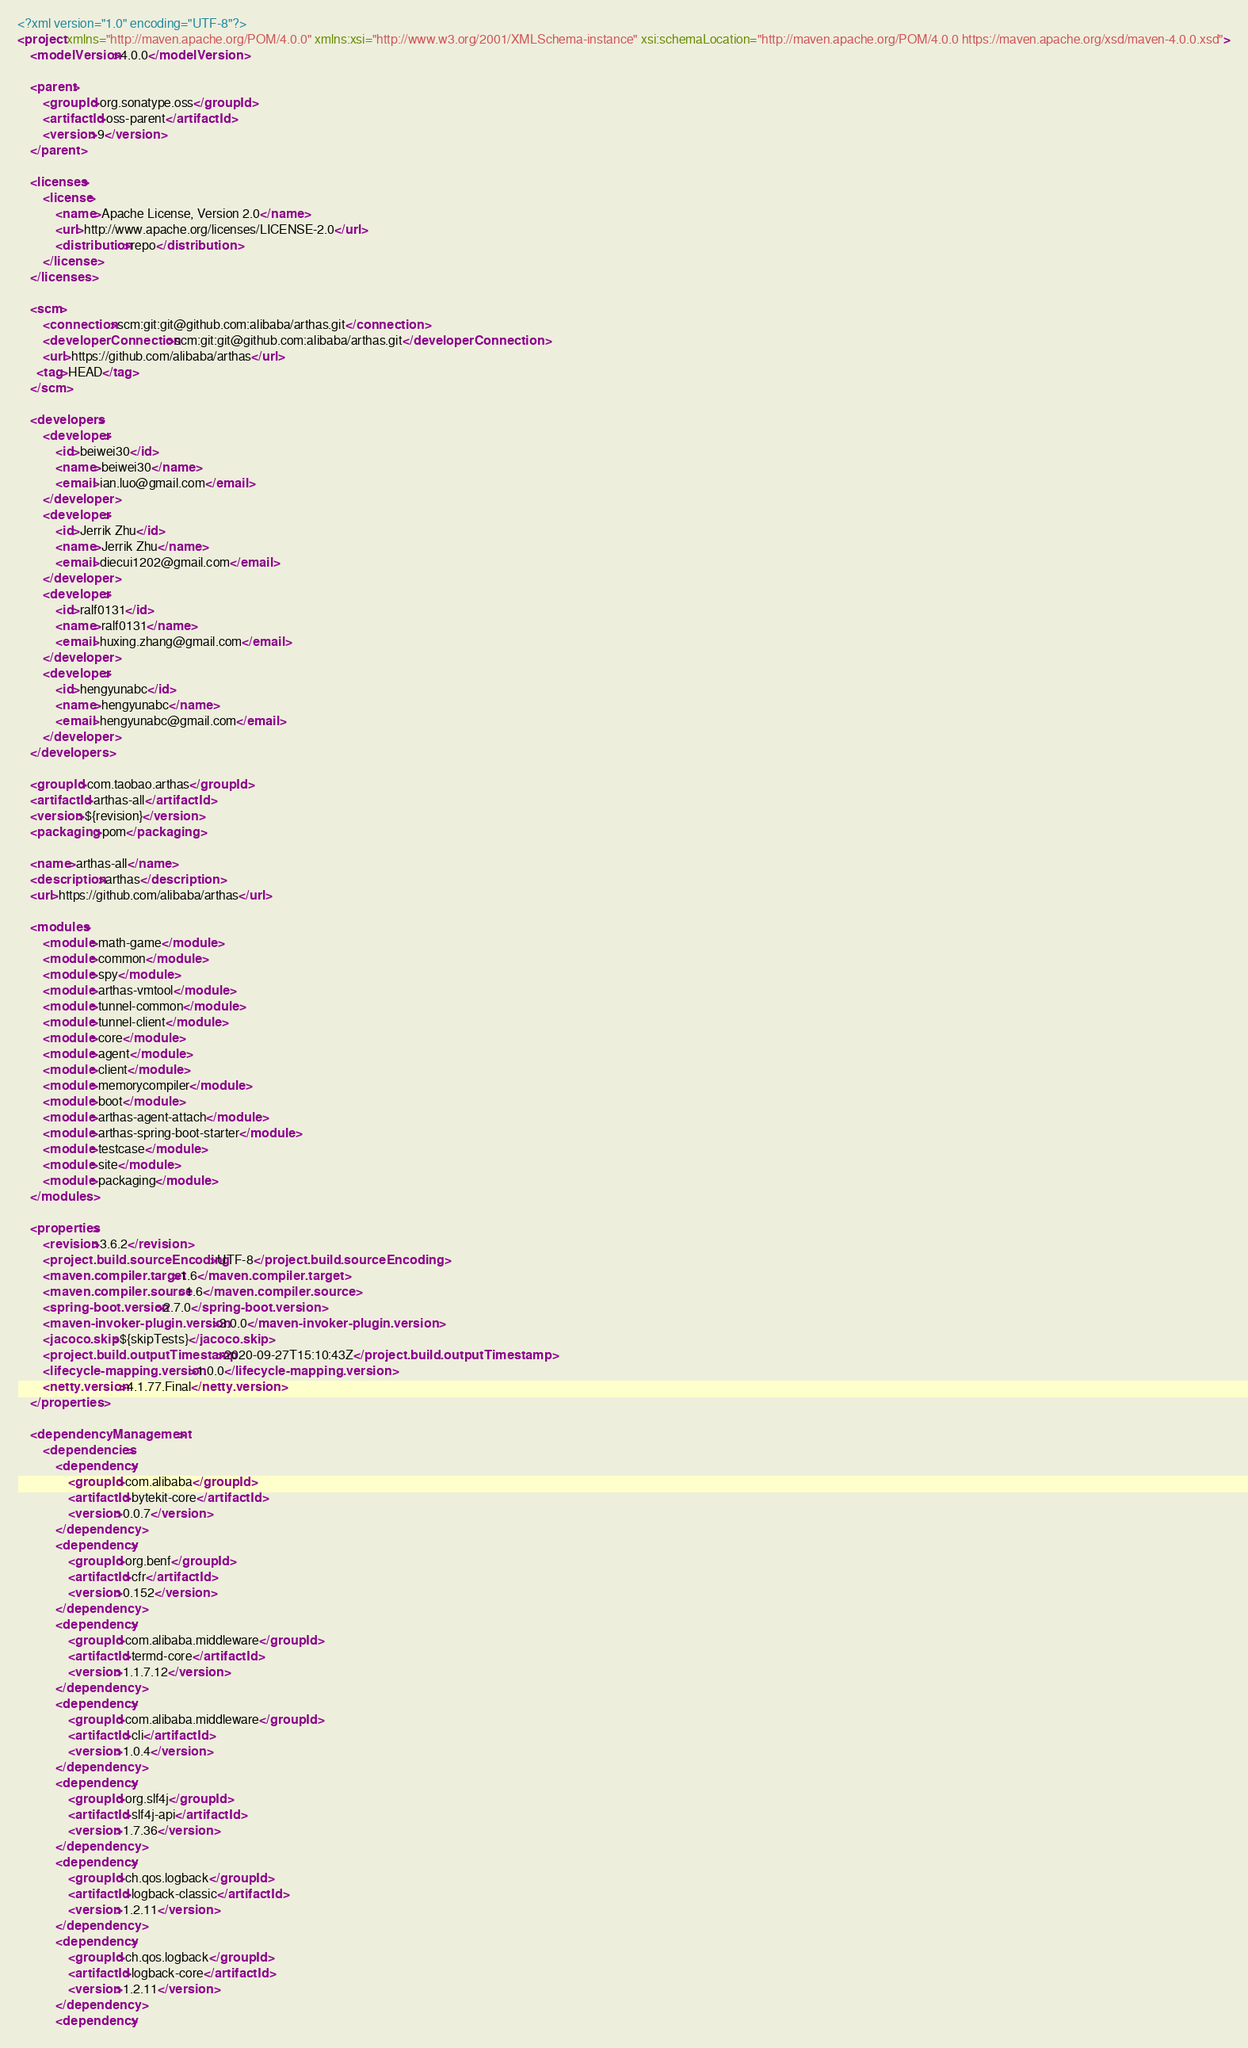<code> <loc_0><loc_0><loc_500><loc_500><_XML_><?xml version="1.0" encoding="UTF-8"?>
<project xmlns="http://maven.apache.org/POM/4.0.0" xmlns:xsi="http://www.w3.org/2001/XMLSchema-instance" xsi:schemaLocation="http://maven.apache.org/POM/4.0.0 https://maven.apache.org/xsd/maven-4.0.0.xsd">
    <modelVersion>4.0.0</modelVersion>

    <parent>
        <groupId>org.sonatype.oss</groupId>
        <artifactId>oss-parent</artifactId>
        <version>9</version>
    </parent>

    <licenses>
        <license>
            <name>Apache License, Version 2.0</name>
            <url>http://www.apache.org/licenses/LICENSE-2.0</url>
            <distribution>repo</distribution>
        </license>
    </licenses>

    <scm>
        <connection>scm:git:git@github.com:alibaba/arthas.git</connection>
        <developerConnection>scm:git:git@github.com:alibaba/arthas.git</developerConnection>
        <url>https://github.com/alibaba/arthas</url>
      <tag>HEAD</tag>
    </scm>

    <developers>
        <developer>
            <id>beiwei30</id>
            <name>beiwei30</name>
            <email>ian.luo@gmail.com</email>
        </developer>
        <developer>
            <id>Jerrik Zhu</id>
            <name>Jerrik Zhu</name>
            <email>diecui1202@gmail.com</email>
        </developer>
        <developer>
            <id>ralf0131</id>
            <name>ralf0131</name>
            <email>huxing.zhang@gmail.com</email>
        </developer>
        <developer>
            <id>hengyunabc</id>
            <name>hengyunabc</name>
            <email>hengyunabc@gmail.com</email>
        </developer>
    </developers>

    <groupId>com.taobao.arthas</groupId>
    <artifactId>arthas-all</artifactId>
    <version>${revision}</version>
    <packaging>pom</packaging>

    <name>arthas-all</name>
    <description>arthas</description>
    <url>https://github.com/alibaba/arthas</url>

    <modules>
        <module>math-game</module>
        <module>common</module>
        <module>spy</module>
        <module>arthas-vmtool</module>
        <module>tunnel-common</module>
        <module>tunnel-client</module>
        <module>core</module>
        <module>agent</module>
        <module>client</module>
        <module>memorycompiler</module>
        <module>boot</module>
        <module>arthas-agent-attach</module>
        <module>arthas-spring-boot-starter</module>
        <module>testcase</module>
        <module>site</module>
        <module>packaging</module>
    </modules>

    <properties>
        <revision>3.6.2</revision>
        <project.build.sourceEncoding>UTF-8</project.build.sourceEncoding>
        <maven.compiler.target>1.6</maven.compiler.target>
        <maven.compiler.source>1.6</maven.compiler.source>
        <spring-boot.version>2.7.0</spring-boot.version>
        <maven-invoker-plugin.version>3.0.0</maven-invoker-plugin.version>
        <jacoco.skip>${skipTests}</jacoco.skip>
        <project.build.outputTimestamp>2020-09-27T15:10:43Z</project.build.outputTimestamp>
        <lifecycle-mapping.version>1.0.0</lifecycle-mapping.version>
        <netty.version>4.1.77.Final</netty.version>
    </properties>

    <dependencyManagement>
        <dependencies>
            <dependency>
                <groupId>com.alibaba</groupId>
                <artifactId>bytekit-core</artifactId>
                <version>0.0.7</version>
            </dependency>
            <dependency>
                <groupId>org.benf</groupId>
                <artifactId>cfr</artifactId>
                <version>0.152</version>
            </dependency>
            <dependency>
                <groupId>com.alibaba.middleware</groupId>
                <artifactId>termd-core</artifactId>
                <version>1.1.7.12</version>
            </dependency>
            <dependency>
                <groupId>com.alibaba.middleware</groupId>
                <artifactId>cli</artifactId>
                <version>1.0.4</version>
            </dependency>
            <dependency>
                <groupId>org.slf4j</groupId>
                <artifactId>slf4j-api</artifactId>
                <version>1.7.36</version>
            </dependency>
            <dependency>
                <groupId>ch.qos.logback</groupId>
                <artifactId>logback-classic</artifactId>
                <version>1.2.11</version>
            </dependency>
            <dependency>
                <groupId>ch.qos.logback</groupId>
                <artifactId>logback-core</artifactId>
                <version>1.2.11</version>
            </dependency>
            <dependency></code> 